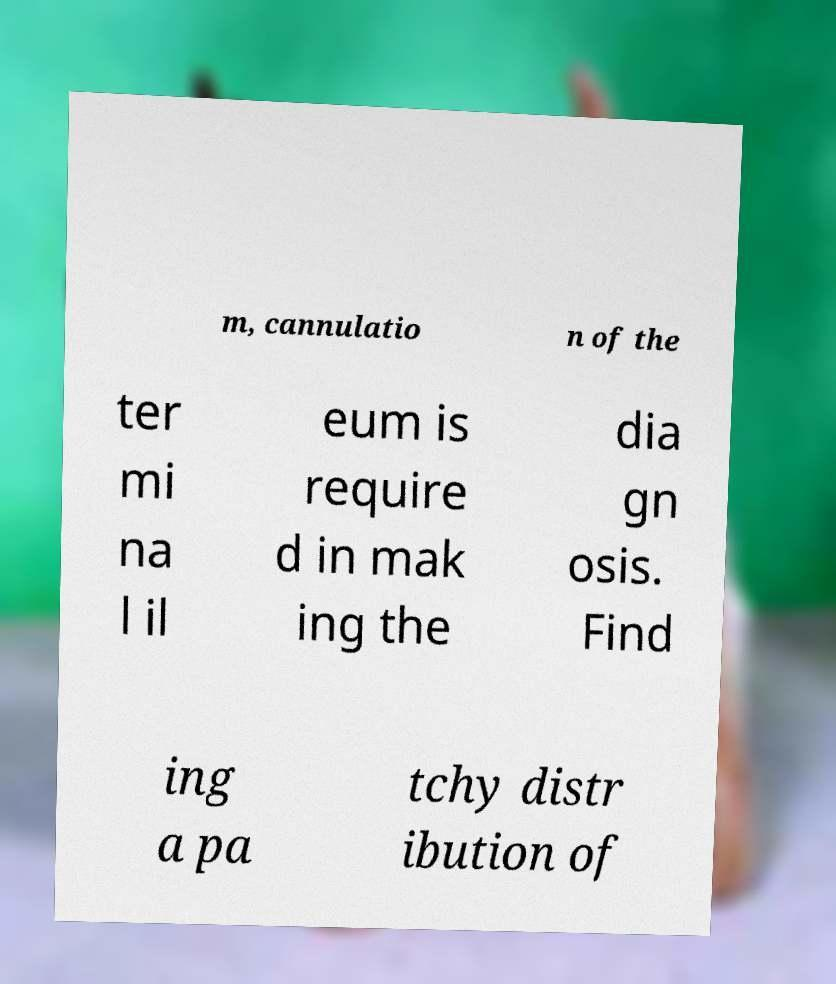Can you accurately transcribe the text from the provided image for me? m, cannulatio n of the ter mi na l il eum is require d in mak ing the dia gn osis. Find ing a pa tchy distr ibution of 